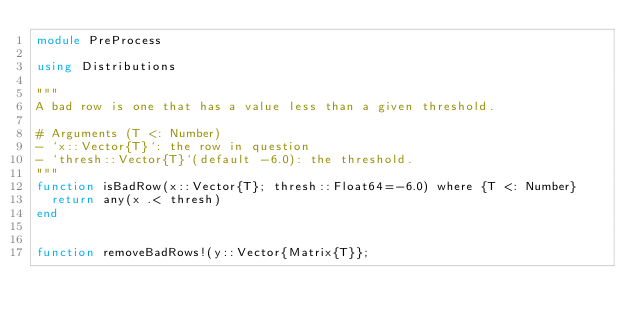Convert code to text. <code><loc_0><loc_0><loc_500><loc_500><_Julia_>module PreProcess

using Distributions

"""
A bad row is one that has a value less than a given threshold.

# Arguments (T <: Number)
- `x::Vector{T}`: the row in question
- `thresh::Vector{T}`(default -6.0): the threshold.
"""
function isBadRow(x::Vector{T}; thresh::Float64=-6.0) where {T <: Number}
  return any(x .< thresh)
end


function removeBadRows!(y::Vector{Matrix{T}};</code> 